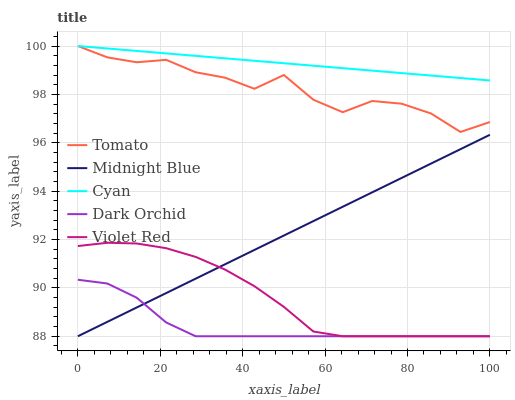Does Dark Orchid have the minimum area under the curve?
Answer yes or no. Yes. Does Cyan have the maximum area under the curve?
Answer yes or no. Yes. Does Violet Red have the minimum area under the curve?
Answer yes or no. No. Does Violet Red have the maximum area under the curve?
Answer yes or no. No. Is Cyan the smoothest?
Answer yes or no. Yes. Is Tomato the roughest?
Answer yes or no. Yes. Is Violet Red the smoothest?
Answer yes or no. No. Is Violet Red the roughest?
Answer yes or no. No. Does Violet Red have the lowest value?
Answer yes or no. Yes. Does Cyan have the lowest value?
Answer yes or no. No. Does Cyan have the highest value?
Answer yes or no. Yes. Does Violet Red have the highest value?
Answer yes or no. No. Is Violet Red less than Tomato?
Answer yes or no. Yes. Is Tomato greater than Midnight Blue?
Answer yes or no. Yes. Does Violet Red intersect Dark Orchid?
Answer yes or no. Yes. Is Violet Red less than Dark Orchid?
Answer yes or no. No. Is Violet Red greater than Dark Orchid?
Answer yes or no. No. Does Violet Red intersect Tomato?
Answer yes or no. No. 